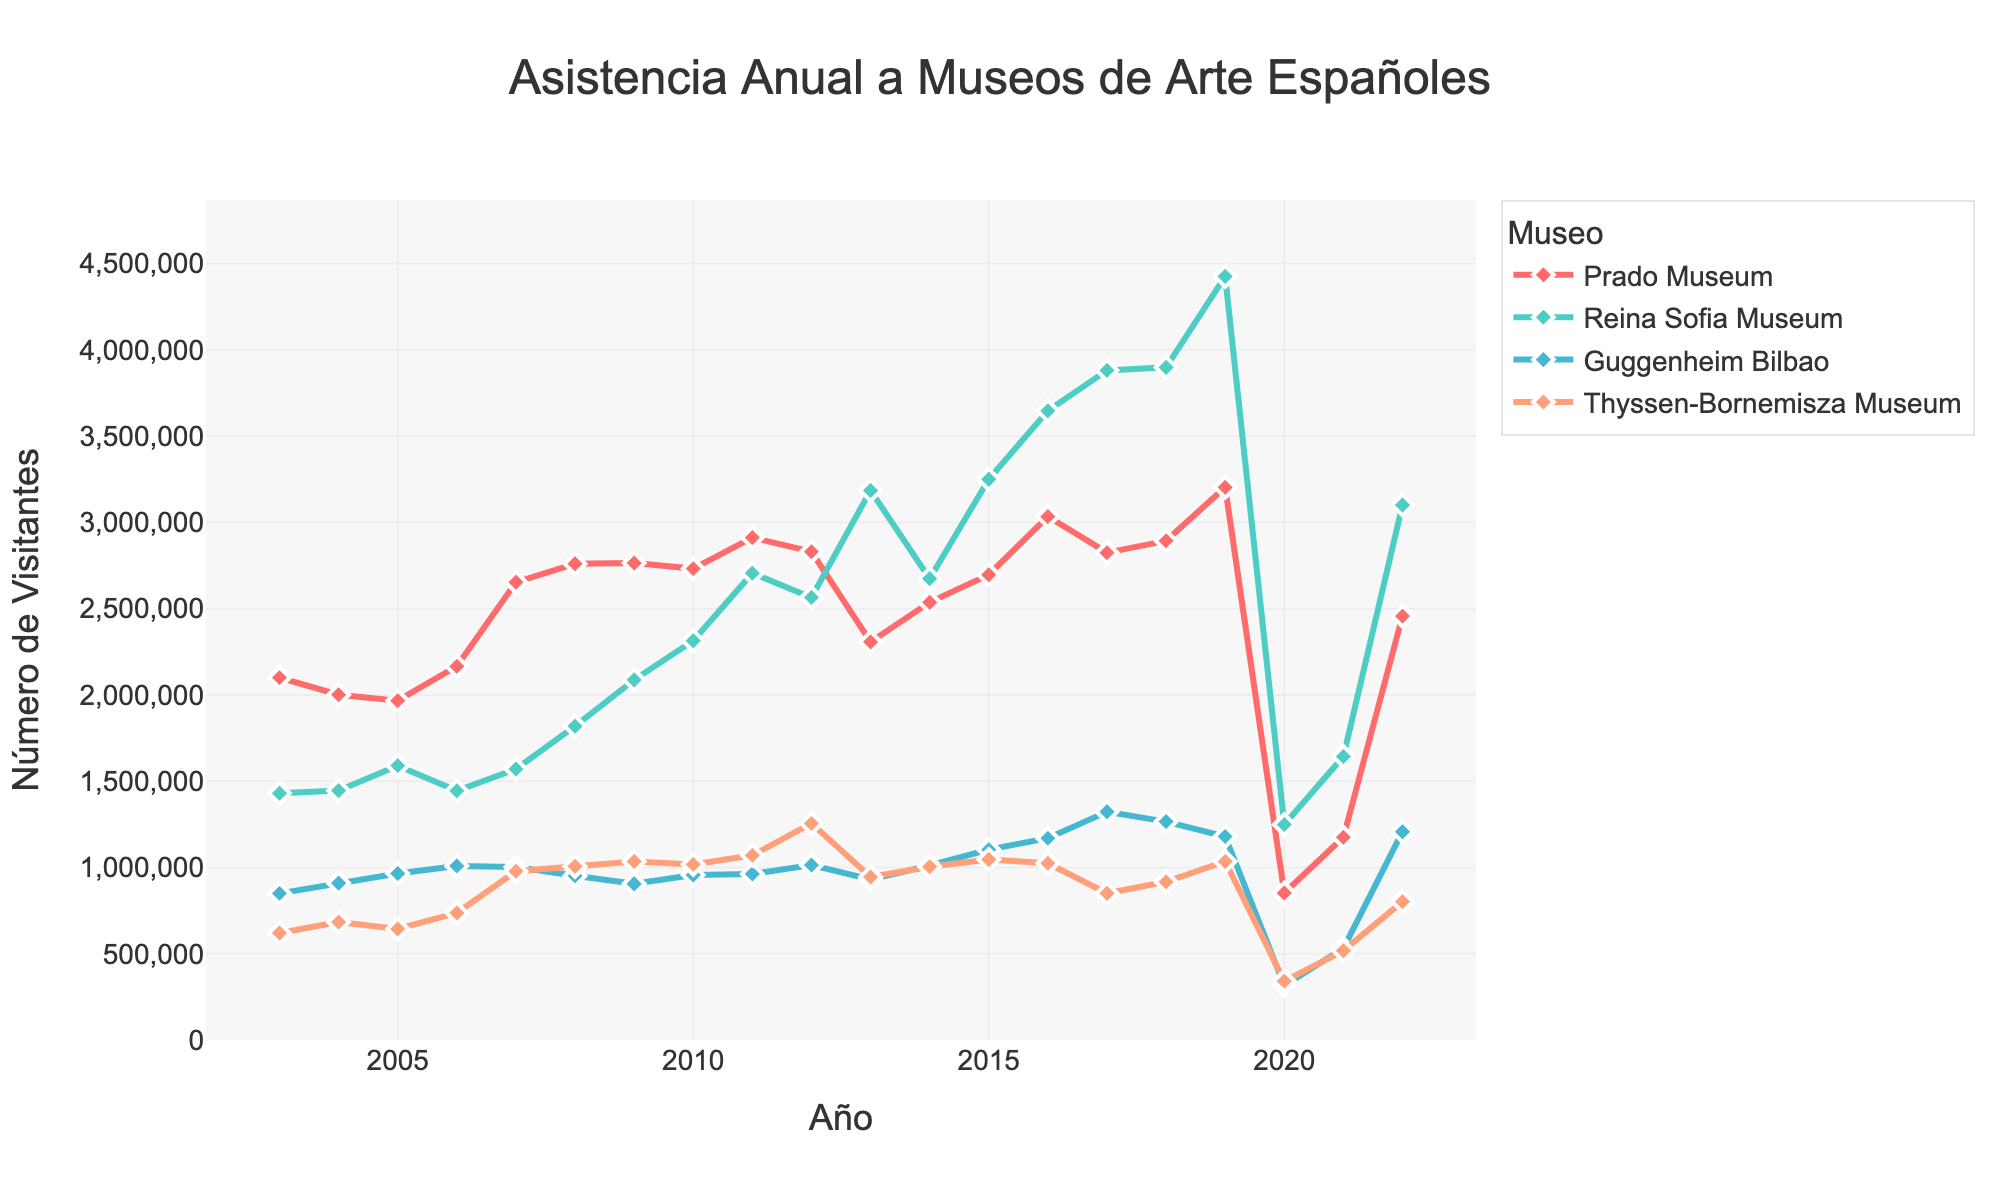What is the overall trend in attendance for the Prado Museum over the two decades? From 2003 to 2019, the Prado Museum generally saw an increasing trend in annual attendance, peaking in 2019 with approximately 3.2 million visitors. However, there was a significant drop in 2020 and 2021 due to the pandemic, followed by a recovery in 2022.
Answer: Increasing trend with a peak in 2019 Which years saw the highest and lowest attendance at the Guggenheim Bilbao? The highest attendance at the Guggenheim Bilbao was in 2017 with 1,322,611 visitors. The lowest attendance was in 2020 with 315,908 visitors.
Answer: 2017 (highest), 2020 (lowest) Compare the attendance figures for the Reina Sofia Museum and Prado Museum in 2015. Which one had more visitors and by how much? In 2015, the Reina Sofia Museum had 3,249,591 visitors, while the Prado Museum had 2,696,666 visitors. The Reina Sofia Museum had 552,925 more visitors.
Answer: Reina Sofia, by 552,925 What is the average annual attendance for the Thyssen-Bornemisza Museum from 2003 to 2019? Sum the attendance figures for the Thyssen-Bornemisza Museum from 2003 to 2019 and divide by 17 (number of years): (620000 + 683484 + 643784 + 736570 + 978064 + 1006654 + 1034773 + 1017608 + 1070390 + 1255281 + 944827 + 1004470 + 1046196 + 1024405 + 850496 + 916784 + 1034941) / 17 = 985,858 (rounded)
Answer: 985,858 Which museum had the highest percentage increase in attendance from 2021 to 2022? Calculate the percentage increase for each museum: Prado (1175078 to 2456724): (2456724-1175078)/1175078 * 100 ≈ 109%, Reina Sofia (1643108 to 3100854): (3100854-1643108)/1643108 * 100 ≈ 89%, Guggenheim (530967 to 1207139): (1207139-530967)/530967 * 100 ≈ 127%, Thyssen-Bornemisza (517741 to 802187): (802187-517741)/517741 * 100 ≈ 55%. So, Guggenheim had the highest percentage increase.
Answer: Guggenheim, 127% How did the attendance at the Thyssen-Bornemisza Museum in 2017 compare to 2018? In 2017, the Thyssen-Bornemisza Museum had 850,496 visitors, whereas in 2018, it had 916,784 visitors. The attendance increased by 66,288 visitors from 2017 to 2018.
Answer: Increased by 66,288 Which museum had the most consistent attendance figures from 2003 to 2019? Evaluating the line smoothness and fluctuations, the Thyssen-Bornemisza Museum shows the most consistent attendance figures without any steep rises or drops over the years compared to other museums.
Answer: Thyssen-Bornemisza Museum In which year did the Reina Sofia Museum first surpass 3 million visitors? The Reina Sofia Museum first surpassed 3 million visitors in 2013, where the attendance surged to 3,184,640.
Answer: 2013 